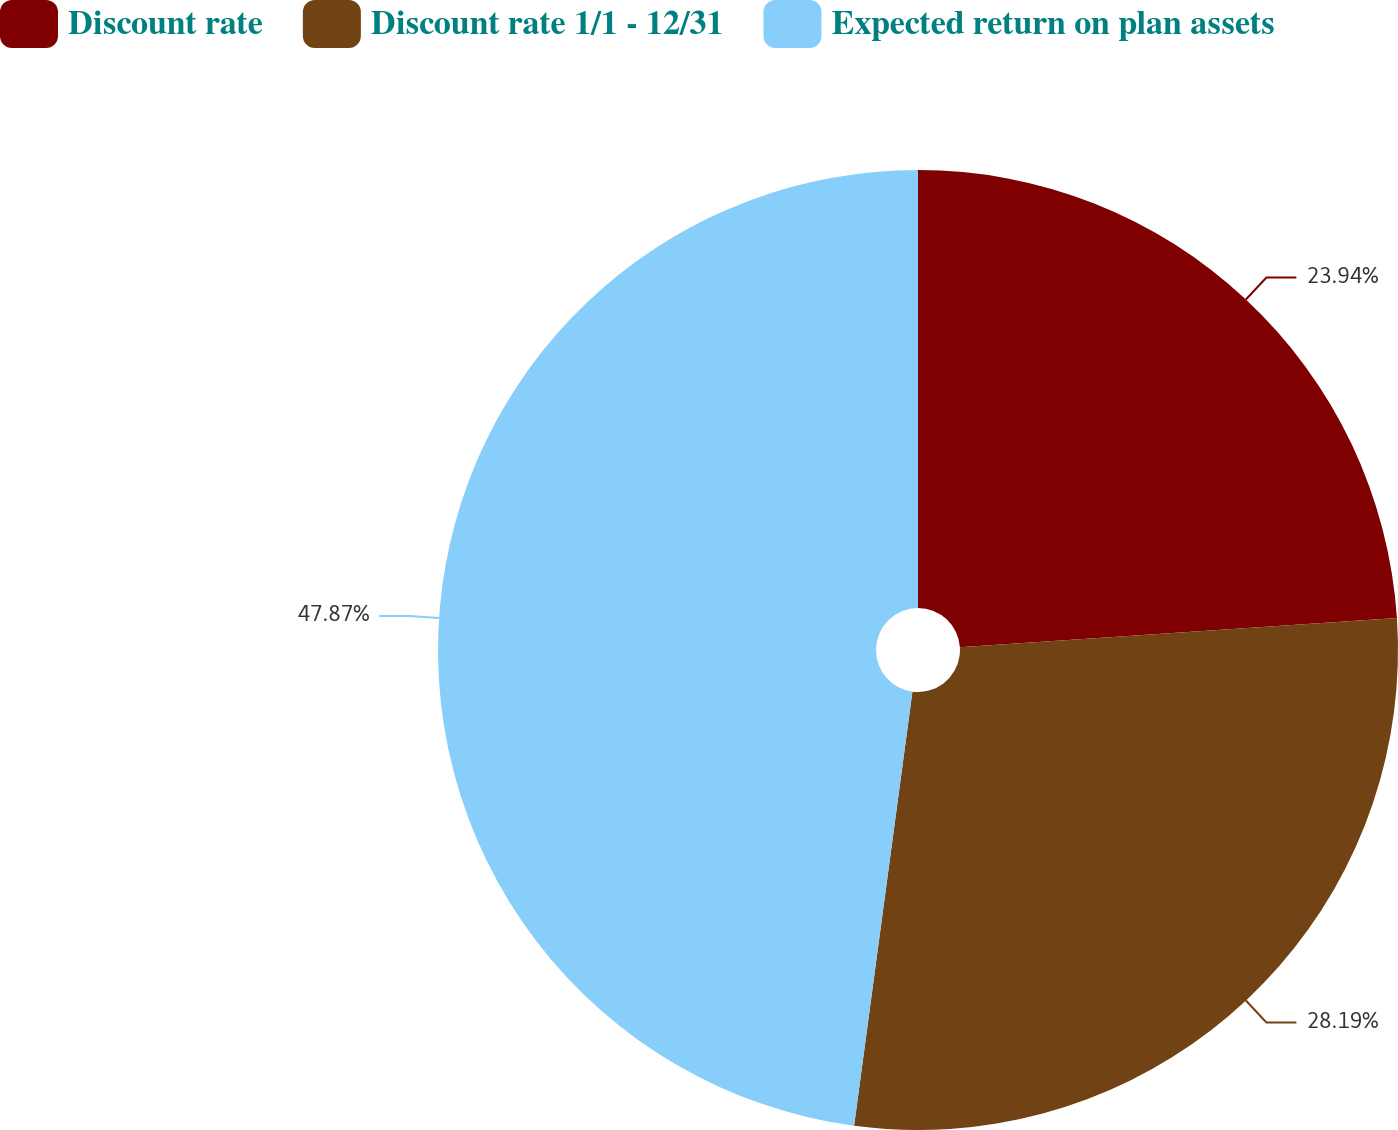<chart> <loc_0><loc_0><loc_500><loc_500><pie_chart><fcel>Discount rate<fcel>Discount rate 1/1 - 12/31<fcel>Expected return on plan assets<nl><fcel>23.94%<fcel>28.19%<fcel>47.88%<nl></chart> 